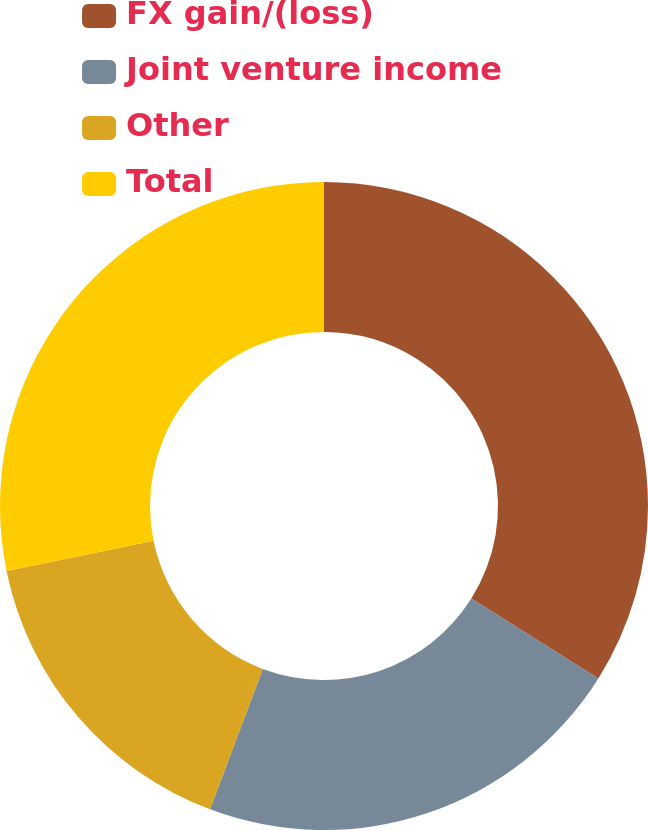Convert chart. <chart><loc_0><loc_0><loc_500><loc_500><pie_chart><fcel>FX gain/(loss)<fcel>Joint venture income<fcel>Other<fcel>Total<nl><fcel>33.93%<fcel>21.79%<fcel>16.07%<fcel>28.21%<nl></chart> 